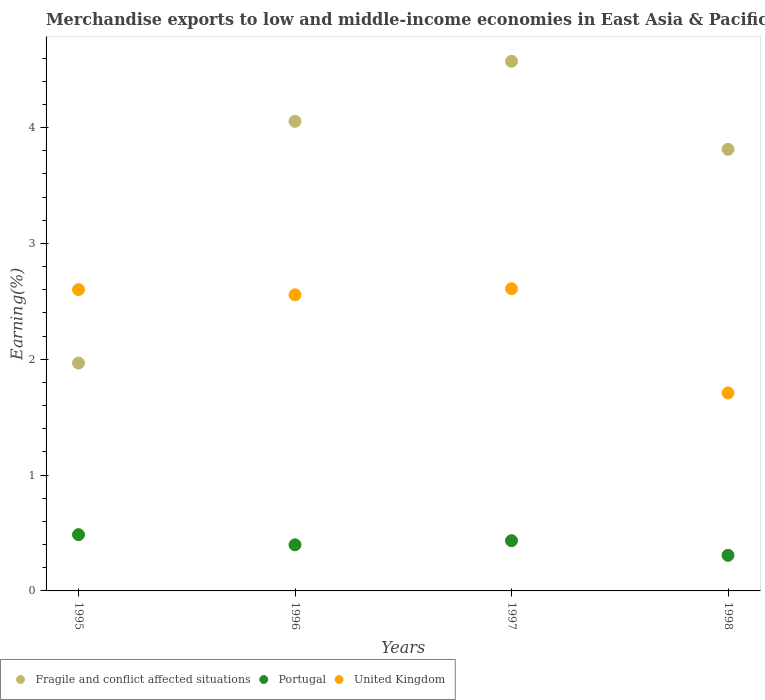How many different coloured dotlines are there?
Your answer should be compact. 3. What is the percentage of amount earned from merchandise exports in United Kingdom in 1998?
Make the answer very short. 1.71. Across all years, what is the maximum percentage of amount earned from merchandise exports in Fragile and conflict affected situations?
Provide a short and direct response. 4.57. Across all years, what is the minimum percentage of amount earned from merchandise exports in United Kingdom?
Provide a short and direct response. 1.71. In which year was the percentage of amount earned from merchandise exports in United Kingdom maximum?
Give a very brief answer. 1997. What is the total percentage of amount earned from merchandise exports in Portugal in the graph?
Provide a succinct answer. 1.62. What is the difference between the percentage of amount earned from merchandise exports in Fragile and conflict affected situations in 1997 and that in 1998?
Your answer should be compact. 0.76. What is the difference between the percentage of amount earned from merchandise exports in Fragile and conflict affected situations in 1997 and the percentage of amount earned from merchandise exports in United Kingdom in 1995?
Provide a succinct answer. 1.97. What is the average percentage of amount earned from merchandise exports in Fragile and conflict affected situations per year?
Keep it short and to the point. 3.6. In the year 1996, what is the difference between the percentage of amount earned from merchandise exports in United Kingdom and percentage of amount earned from merchandise exports in Portugal?
Offer a terse response. 2.16. What is the ratio of the percentage of amount earned from merchandise exports in Fragile and conflict affected situations in 1995 to that in 1997?
Your response must be concise. 0.43. Is the difference between the percentage of amount earned from merchandise exports in United Kingdom in 1996 and 1997 greater than the difference between the percentage of amount earned from merchandise exports in Portugal in 1996 and 1997?
Provide a succinct answer. No. What is the difference between the highest and the second highest percentage of amount earned from merchandise exports in Fragile and conflict affected situations?
Your response must be concise. 0.52. What is the difference between the highest and the lowest percentage of amount earned from merchandise exports in Portugal?
Offer a very short reply. 0.18. Is the sum of the percentage of amount earned from merchandise exports in Portugal in 1995 and 1996 greater than the maximum percentage of amount earned from merchandise exports in United Kingdom across all years?
Keep it short and to the point. No. Is the percentage of amount earned from merchandise exports in United Kingdom strictly less than the percentage of amount earned from merchandise exports in Fragile and conflict affected situations over the years?
Provide a short and direct response. No. How many dotlines are there?
Your response must be concise. 3. How many years are there in the graph?
Offer a very short reply. 4. What is the difference between two consecutive major ticks on the Y-axis?
Offer a very short reply. 1. Does the graph contain any zero values?
Offer a very short reply. No. Does the graph contain grids?
Your answer should be compact. No. Where does the legend appear in the graph?
Provide a short and direct response. Bottom left. What is the title of the graph?
Give a very brief answer. Merchandise exports to low and middle-income economies in East Asia & Pacific. Does "Morocco" appear as one of the legend labels in the graph?
Offer a terse response. No. What is the label or title of the Y-axis?
Provide a succinct answer. Earning(%). What is the Earning(%) in Fragile and conflict affected situations in 1995?
Provide a succinct answer. 1.97. What is the Earning(%) of Portugal in 1995?
Provide a succinct answer. 0.49. What is the Earning(%) of United Kingdom in 1995?
Ensure brevity in your answer.  2.6. What is the Earning(%) of Fragile and conflict affected situations in 1996?
Keep it short and to the point. 4.05. What is the Earning(%) of Portugal in 1996?
Provide a succinct answer. 0.4. What is the Earning(%) in United Kingdom in 1996?
Give a very brief answer. 2.56. What is the Earning(%) of Fragile and conflict affected situations in 1997?
Your response must be concise. 4.57. What is the Earning(%) of Portugal in 1997?
Your answer should be very brief. 0.43. What is the Earning(%) in United Kingdom in 1997?
Provide a short and direct response. 2.61. What is the Earning(%) of Fragile and conflict affected situations in 1998?
Make the answer very short. 3.81. What is the Earning(%) of Portugal in 1998?
Make the answer very short. 0.31. What is the Earning(%) in United Kingdom in 1998?
Give a very brief answer. 1.71. Across all years, what is the maximum Earning(%) in Fragile and conflict affected situations?
Provide a short and direct response. 4.57. Across all years, what is the maximum Earning(%) in Portugal?
Ensure brevity in your answer.  0.49. Across all years, what is the maximum Earning(%) in United Kingdom?
Keep it short and to the point. 2.61. Across all years, what is the minimum Earning(%) in Fragile and conflict affected situations?
Keep it short and to the point. 1.97. Across all years, what is the minimum Earning(%) of Portugal?
Offer a terse response. 0.31. Across all years, what is the minimum Earning(%) of United Kingdom?
Ensure brevity in your answer.  1.71. What is the total Earning(%) of Fragile and conflict affected situations in the graph?
Offer a very short reply. 14.4. What is the total Earning(%) in Portugal in the graph?
Your response must be concise. 1.62. What is the total Earning(%) of United Kingdom in the graph?
Your answer should be compact. 9.48. What is the difference between the Earning(%) in Fragile and conflict affected situations in 1995 and that in 1996?
Provide a succinct answer. -2.09. What is the difference between the Earning(%) in Portugal in 1995 and that in 1996?
Your response must be concise. 0.09. What is the difference between the Earning(%) of United Kingdom in 1995 and that in 1996?
Your answer should be very brief. 0.04. What is the difference between the Earning(%) of Fragile and conflict affected situations in 1995 and that in 1997?
Your answer should be very brief. -2.61. What is the difference between the Earning(%) in Portugal in 1995 and that in 1997?
Make the answer very short. 0.05. What is the difference between the Earning(%) of United Kingdom in 1995 and that in 1997?
Make the answer very short. -0.01. What is the difference between the Earning(%) in Fragile and conflict affected situations in 1995 and that in 1998?
Your answer should be very brief. -1.85. What is the difference between the Earning(%) in Portugal in 1995 and that in 1998?
Offer a very short reply. 0.18. What is the difference between the Earning(%) in United Kingdom in 1995 and that in 1998?
Ensure brevity in your answer.  0.89. What is the difference between the Earning(%) in Fragile and conflict affected situations in 1996 and that in 1997?
Provide a succinct answer. -0.52. What is the difference between the Earning(%) in Portugal in 1996 and that in 1997?
Your response must be concise. -0.04. What is the difference between the Earning(%) of United Kingdom in 1996 and that in 1997?
Offer a very short reply. -0.05. What is the difference between the Earning(%) in Fragile and conflict affected situations in 1996 and that in 1998?
Give a very brief answer. 0.24. What is the difference between the Earning(%) in Portugal in 1996 and that in 1998?
Your answer should be very brief. 0.09. What is the difference between the Earning(%) in United Kingdom in 1996 and that in 1998?
Ensure brevity in your answer.  0.85. What is the difference between the Earning(%) of Fragile and conflict affected situations in 1997 and that in 1998?
Keep it short and to the point. 0.76. What is the difference between the Earning(%) in Portugal in 1997 and that in 1998?
Offer a very short reply. 0.13. What is the difference between the Earning(%) in United Kingdom in 1997 and that in 1998?
Your answer should be very brief. 0.9. What is the difference between the Earning(%) of Fragile and conflict affected situations in 1995 and the Earning(%) of Portugal in 1996?
Offer a very short reply. 1.57. What is the difference between the Earning(%) in Fragile and conflict affected situations in 1995 and the Earning(%) in United Kingdom in 1996?
Make the answer very short. -0.59. What is the difference between the Earning(%) of Portugal in 1995 and the Earning(%) of United Kingdom in 1996?
Give a very brief answer. -2.07. What is the difference between the Earning(%) of Fragile and conflict affected situations in 1995 and the Earning(%) of Portugal in 1997?
Your answer should be compact. 1.53. What is the difference between the Earning(%) in Fragile and conflict affected situations in 1995 and the Earning(%) in United Kingdom in 1997?
Keep it short and to the point. -0.64. What is the difference between the Earning(%) in Portugal in 1995 and the Earning(%) in United Kingdom in 1997?
Ensure brevity in your answer.  -2.12. What is the difference between the Earning(%) in Fragile and conflict affected situations in 1995 and the Earning(%) in Portugal in 1998?
Offer a terse response. 1.66. What is the difference between the Earning(%) in Fragile and conflict affected situations in 1995 and the Earning(%) in United Kingdom in 1998?
Your response must be concise. 0.26. What is the difference between the Earning(%) of Portugal in 1995 and the Earning(%) of United Kingdom in 1998?
Your answer should be compact. -1.22. What is the difference between the Earning(%) in Fragile and conflict affected situations in 1996 and the Earning(%) in Portugal in 1997?
Offer a very short reply. 3.62. What is the difference between the Earning(%) of Fragile and conflict affected situations in 1996 and the Earning(%) of United Kingdom in 1997?
Keep it short and to the point. 1.45. What is the difference between the Earning(%) of Portugal in 1996 and the Earning(%) of United Kingdom in 1997?
Provide a succinct answer. -2.21. What is the difference between the Earning(%) in Fragile and conflict affected situations in 1996 and the Earning(%) in Portugal in 1998?
Your answer should be very brief. 3.75. What is the difference between the Earning(%) of Fragile and conflict affected situations in 1996 and the Earning(%) of United Kingdom in 1998?
Your answer should be compact. 2.34. What is the difference between the Earning(%) in Portugal in 1996 and the Earning(%) in United Kingdom in 1998?
Your response must be concise. -1.31. What is the difference between the Earning(%) in Fragile and conflict affected situations in 1997 and the Earning(%) in Portugal in 1998?
Your answer should be very brief. 4.26. What is the difference between the Earning(%) of Fragile and conflict affected situations in 1997 and the Earning(%) of United Kingdom in 1998?
Offer a terse response. 2.86. What is the difference between the Earning(%) in Portugal in 1997 and the Earning(%) in United Kingdom in 1998?
Ensure brevity in your answer.  -1.28. What is the average Earning(%) of Fragile and conflict affected situations per year?
Give a very brief answer. 3.6. What is the average Earning(%) in Portugal per year?
Give a very brief answer. 0.41. What is the average Earning(%) in United Kingdom per year?
Your answer should be very brief. 2.37. In the year 1995, what is the difference between the Earning(%) in Fragile and conflict affected situations and Earning(%) in Portugal?
Make the answer very short. 1.48. In the year 1995, what is the difference between the Earning(%) of Fragile and conflict affected situations and Earning(%) of United Kingdom?
Give a very brief answer. -0.63. In the year 1995, what is the difference between the Earning(%) in Portugal and Earning(%) in United Kingdom?
Ensure brevity in your answer.  -2.12. In the year 1996, what is the difference between the Earning(%) of Fragile and conflict affected situations and Earning(%) of Portugal?
Offer a very short reply. 3.66. In the year 1996, what is the difference between the Earning(%) of Fragile and conflict affected situations and Earning(%) of United Kingdom?
Your response must be concise. 1.5. In the year 1996, what is the difference between the Earning(%) in Portugal and Earning(%) in United Kingdom?
Your answer should be compact. -2.16. In the year 1997, what is the difference between the Earning(%) of Fragile and conflict affected situations and Earning(%) of Portugal?
Your answer should be very brief. 4.14. In the year 1997, what is the difference between the Earning(%) in Fragile and conflict affected situations and Earning(%) in United Kingdom?
Keep it short and to the point. 1.96. In the year 1997, what is the difference between the Earning(%) of Portugal and Earning(%) of United Kingdom?
Your response must be concise. -2.17. In the year 1998, what is the difference between the Earning(%) of Fragile and conflict affected situations and Earning(%) of Portugal?
Your answer should be very brief. 3.5. In the year 1998, what is the difference between the Earning(%) in Fragile and conflict affected situations and Earning(%) in United Kingdom?
Your answer should be compact. 2.1. In the year 1998, what is the difference between the Earning(%) of Portugal and Earning(%) of United Kingdom?
Keep it short and to the point. -1.4. What is the ratio of the Earning(%) in Fragile and conflict affected situations in 1995 to that in 1996?
Make the answer very short. 0.49. What is the ratio of the Earning(%) in Portugal in 1995 to that in 1996?
Provide a short and direct response. 1.22. What is the ratio of the Earning(%) of United Kingdom in 1995 to that in 1996?
Keep it short and to the point. 1.02. What is the ratio of the Earning(%) of Fragile and conflict affected situations in 1995 to that in 1997?
Ensure brevity in your answer.  0.43. What is the ratio of the Earning(%) in Portugal in 1995 to that in 1997?
Ensure brevity in your answer.  1.12. What is the ratio of the Earning(%) in United Kingdom in 1995 to that in 1997?
Give a very brief answer. 1. What is the ratio of the Earning(%) in Fragile and conflict affected situations in 1995 to that in 1998?
Your answer should be very brief. 0.52. What is the ratio of the Earning(%) of Portugal in 1995 to that in 1998?
Give a very brief answer. 1.58. What is the ratio of the Earning(%) in United Kingdom in 1995 to that in 1998?
Keep it short and to the point. 1.52. What is the ratio of the Earning(%) of Fragile and conflict affected situations in 1996 to that in 1997?
Ensure brevity in your answer.  0.89. What is the ratio of the Earning(%) in Portugal in 1996 to that in 1997?
Make the answer very short. 0.92. What is the ratio of the Earning(%) of United Kingdom in 1996 to that in 1997?
Your answer should be compact. 0.98. What is the ratio of the Earning(%) in Fragile and conflict affected situations in 1996 to that in 1998?
Your answer should be compact. 1.06. What is the ratio of the Earning(%) in Portugal in 1996 to that in 1998?
Give a very brief answer. 1.3. What is the ratio of the Earning(%) in United Kingdom in 1996 to that in 1998?
Offer a terse response. 1.5. What is the ratio of the Earning(%) of Fragile and conflict affected situations in 1997 to that in 1998?
Your response must be concise. 1.2. What is the ratio of the Earning(%) of Portugal in 1997 to that in 1998?
Make the answer very short. 1.41. What is the ratio of the Earning(%) in United Kingdom in 1997 to that in 1998?
Keep it short and to the point. 1.53. What is the difference between the highest and the second highest Earning(%) of Fragile and conflict affected situations?
Your answer should be compact. 0.52. What is the difference between the highest and the second highest Earning(%) of Portugal?
Give a very brief answer. 0.05. What is the difference between the highest and the second highest Earning(%) in United Kingdom?
Ensure brevity in your answer.  0.01. What is the difference between the highest and the lowest Earning(%) of Fragile and conflict affected situations?
Ensure brevity in your answer.  2.61. What is the difference between the highest and the lowest Earning(%) in Portugal?
Give a very brief answer. 0.18. What is the difference between the highest and the lowest Earning(%) in United Kingdom?
Make the answer very short. 0.9. 